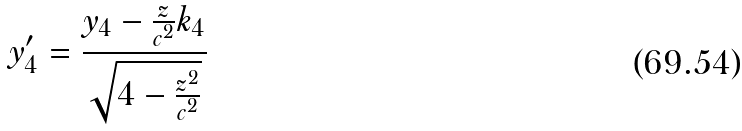<formula> <loc_0><loc_0><loc_500><loc_500>y _ { 4 } ^ { \prime } = \frac { y _ { 4 } - \frac { z } { c ^ { 2 } } k _ { 4 } } { \sqrt { 4 - \frac { z ^ { 2 } } { c ^ { 2 } } } }</formula> 